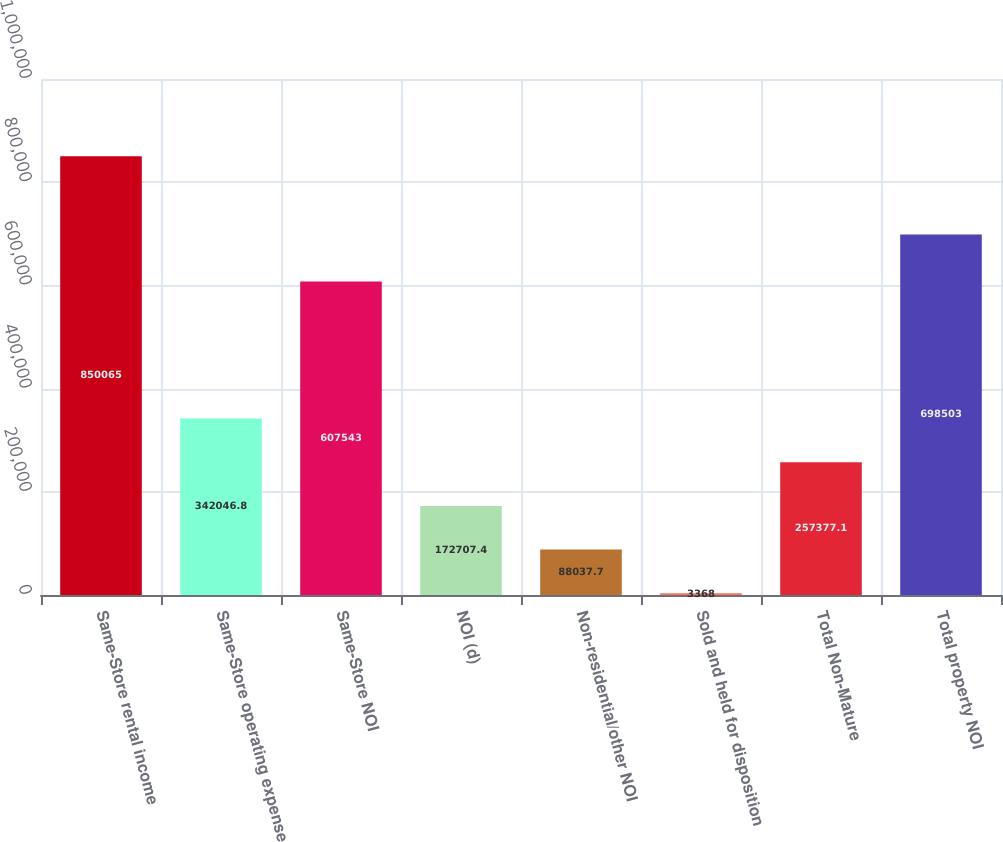Convert chart to OTSL. <chart><loc_0><loc_0><loc_500><loc_500><bar_chart><fcel>Same-Store rental income<fcel>Same-Store operating expense<fcel>Same-Store NOI<fcel>NOI (d)<fcel>Non-residential/other NOI<fcel>Sold and held for disposition<fcel>Total Non-Mature<fcel>Total property NOI<nl><fcel>850065<fcel>342047<fcel>607543<fcel>172707<fcel>88037.7<fcel>3368<fcel>257377<fcel>698503<nl></chart> 